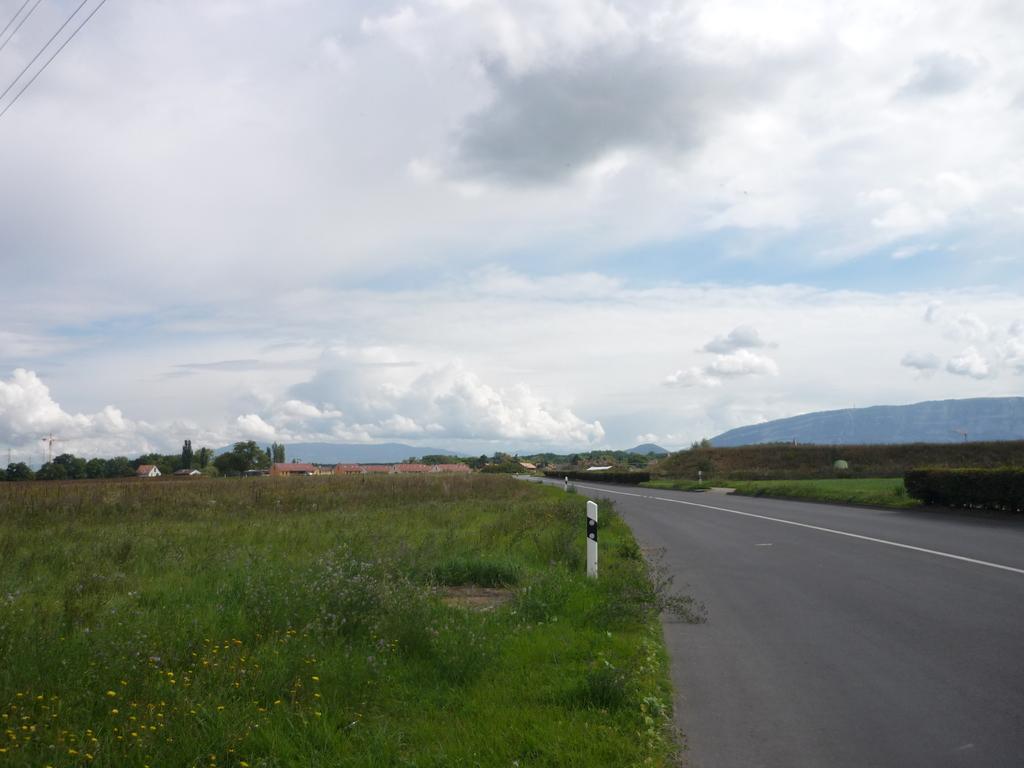How would you summarize this image in a sentence or two? In this image I see the road and I see the grass on the sides. In the background I see the trees and I see few houses and I see the sky which is a bit cloudy and I see the white and black color pole over here. 